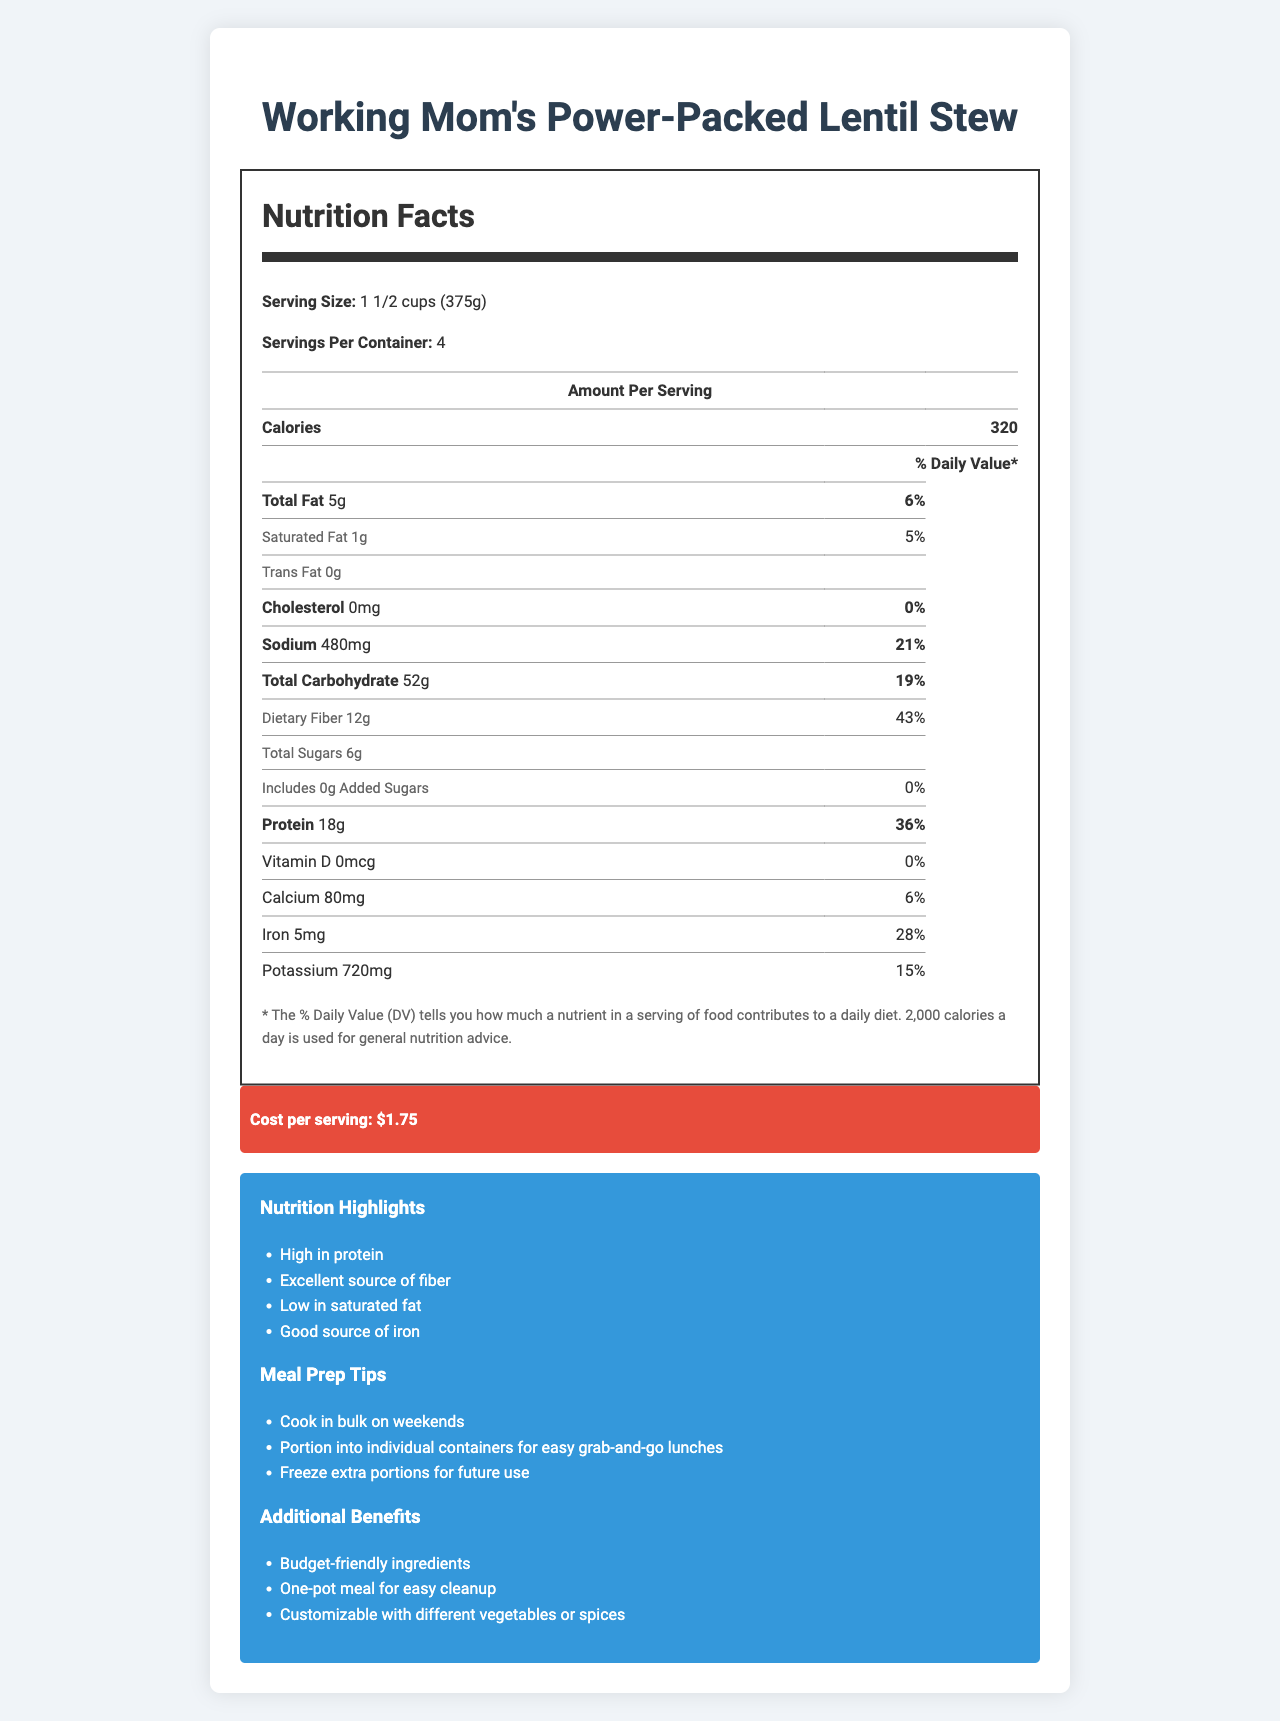What is the serving size of Working Mom's Power-Packed Lentil Stew? The serving size is listed as 1 1/2 cups (375g).
Answer: 1 1/2 cups (375g) How many servings are there per container? The document states there are 4 servings per container.
Answer: 4 What is the total amount of protein per serving? The total protein content per serving is given as 18g.
Answer: 18g How many grams of dietary fiber are in one serving? The dietary fiber content per serving is specified as 12g.
Answer: 12g What percentage of the daily value of iron does one serving provide? The percentage daily value for iron is listed as 28%.
Answer: 28% How much sodium is in one serving of the stew? A. 320mg B. 480mg C. 720mg D. 1020mg The sodium content per serving is specified as 480mg.
Answer: B. 480mg Which of the following nutrients is NOT present in the stew? A. Vitamin D B. Calcium C. Iron D. Carbohydrates The Vitamin D content is 0 mcg, which means there is no Vitamin D in the stew.
Answer: A. Vitamin D Is this product free of allergens? The document mentions "None" under allergens.
Answer: Yes Can this product be stored in a freezer? The storage instructions indicate that the stew can be frozen for up to 3 months.
Answer: Yes Summarize the main idea of the document. The document is a detailed nutrition label for a budget-friendly, high-protein lentil stew aimed at busy working mothers, highlighting its nutritional benefits, cost, cooking instructions, and additional advantages like meal prep tips and customization options.
Answer: A Nutrition Facts Label for "Working Mom's Power-Packed Lentil Stew" providing details on serving size, nutritional content (such as calories, fats, proteins, vitamins, and minerals), cost per serving, preparation and cooking time, storage, and additional meal prep tips and benefits. What are the main ingredients used in the stew? The main ingredients are listed as Lentils, Carrots, Onions, Celery, Canned Diced Tomatoes, Vegetable Broth, and Spinach.
Answer: Lentils, Carrots, Onions, Celery, Canned Diced Tomatoes, Vegetable Broth, Spinach What is the total carbohydrate content per serving? The total carbohydrate content per serving is specified as 52g.
Answer: 52g Is there any added sugar in the stew? The document states there are 0g of added sugars per serving.
Answer: No How much does one serving of the stew cost? The cost per serving is listed as $1.75.
Answer: $1.75 Which of the following is NOT a meal prep tip mentioned in the document? A. Cook in bulk on weekends B. Use a slow cooker C. Portion into individual containers for easy grab-and-go lunches D. Freeze extra portions for future use The meal prep tips include cooking in bulk on weekends, portioning into individual containers, and freezing extra portions, but do not mention using a slow cooker.
Answer: B. Use a slow cooker Can the potassium content be determined from the document? The potassium content per serving is 720mg, with a daily value percentage of 15%.
Answer: Yes What is the cooking time for the stew? The cooking time is listed as 30 minutes.
Answer: 30 minutes What additional benefits does the stew offer? The additional benefits mentioned are budget-friendly ingredients, one-pot meal for easy cleanup, and customization with different vegetables or spices.
Answer: Budget-friendly ingredients, One-pot meal for easy cleanup, Customizable with different vegetables or spices How is the stew reheated? The reheating instructions specify microwaving for 2-3 minutes or heating on a stovetop until thoroughly warm.
Answer: Microwave for 2-3 minutes or heat on stovetop until thoroughly warm What vitamins are present in the stew? The document does not provide sufficient detailed information on vitamins beyond Vitamin D and Calcium and their amounts.
Answer: Not enough information 